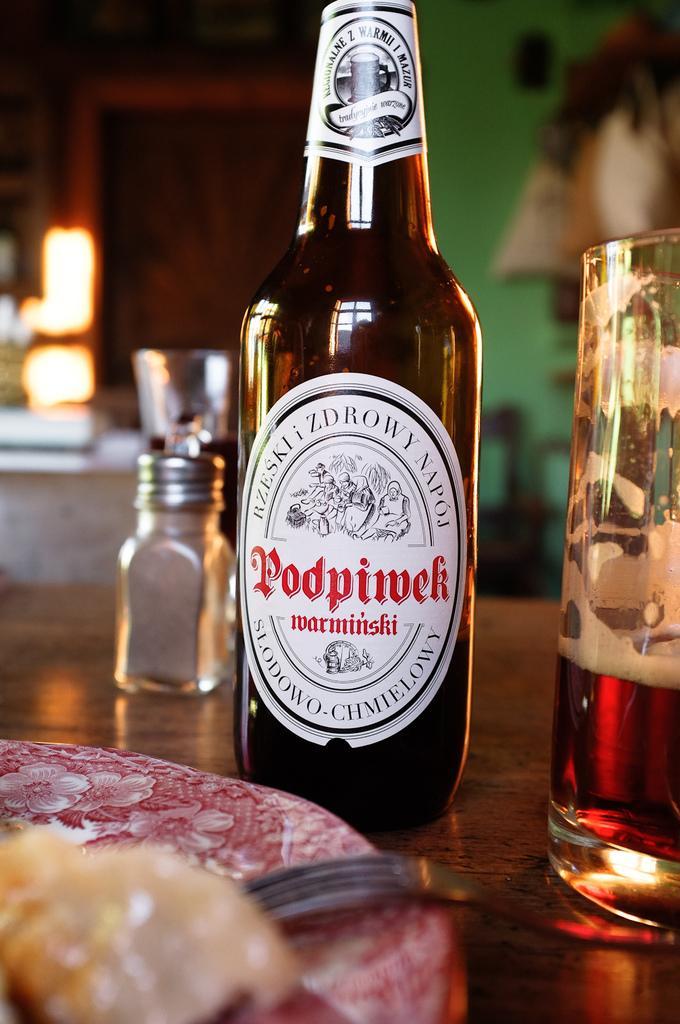Describe this image in one or two sentences. In the picture,there is a table on the table there is a bottle beside the bottle there is a pepper, to the right right there is a glass and some drink in the class ,there is a red color purse front of the bottle in the background there is a green color wall. 